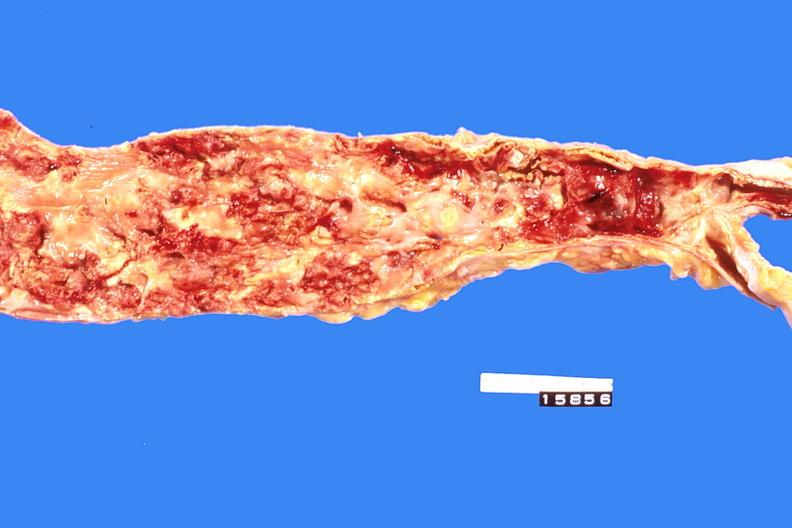does muscle atrophy show abdominal aorta, severe atherosclerosis?
Answer the question using a single word or phrase. No 